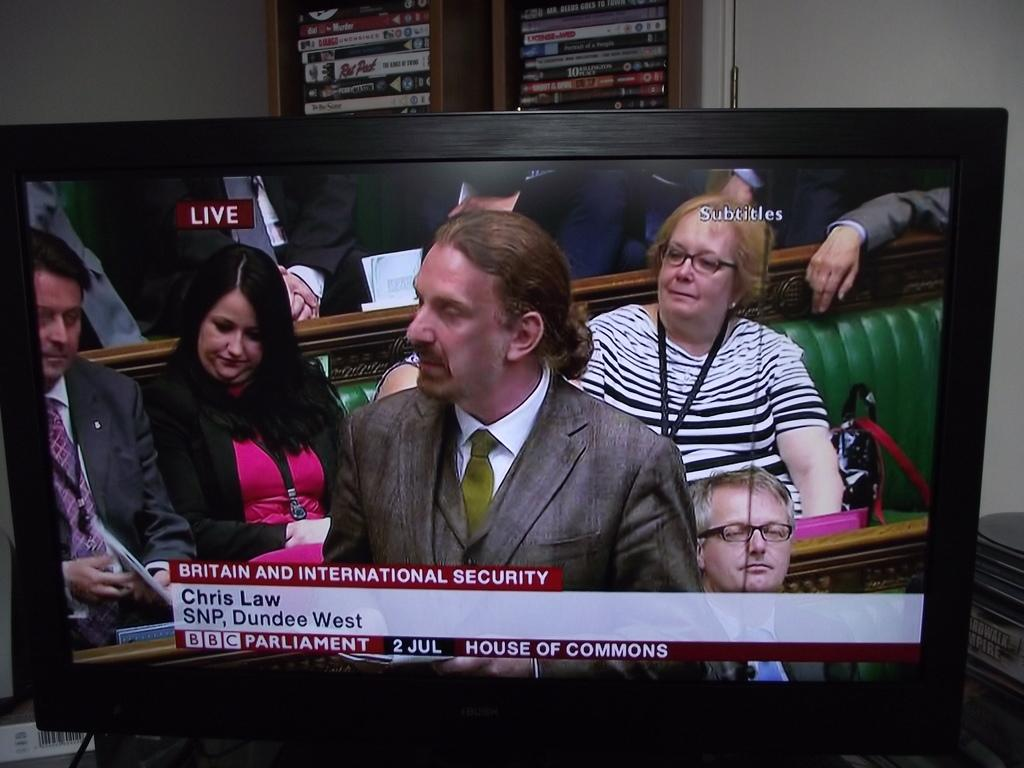<image>
Share a concise interpretation of the image provided. On a tv, a man named Chris Law speaks in the house of commons. 